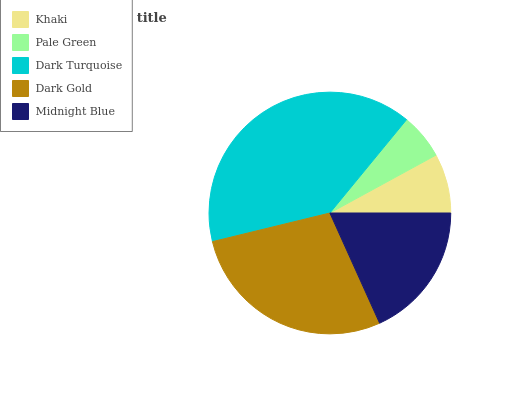Is Pale Green the minimum?
Answer yes or no. Yes. Is Dark Turquoise the maximum?
Answer yes or no. Yes. Is Dark Turquoise the minimum?
Answer yes or no. No. Is Pale Green the maximum?
Answer yes or no. No. Is Dark Turquoise greater than Pale Green?
Answer yes or no. Yes. Is Pale Green less than Dark Turquoise?
Answer yes or no. Yes. Is Pale Green greater than Dark Turquoise?
Answer yes or no. No. Is Dark Turquoise less than Pale Green?
Answer yes or no. No. Is Midnight Blue the high median?
Answer yes or no. Yes. Is Midnight Blue the low median?
Answer yes or no. Yes. Is Khaki the high median?
Answer yes or no. No. Is Dark Turquoise the low median?
Answer yes or no. No. 